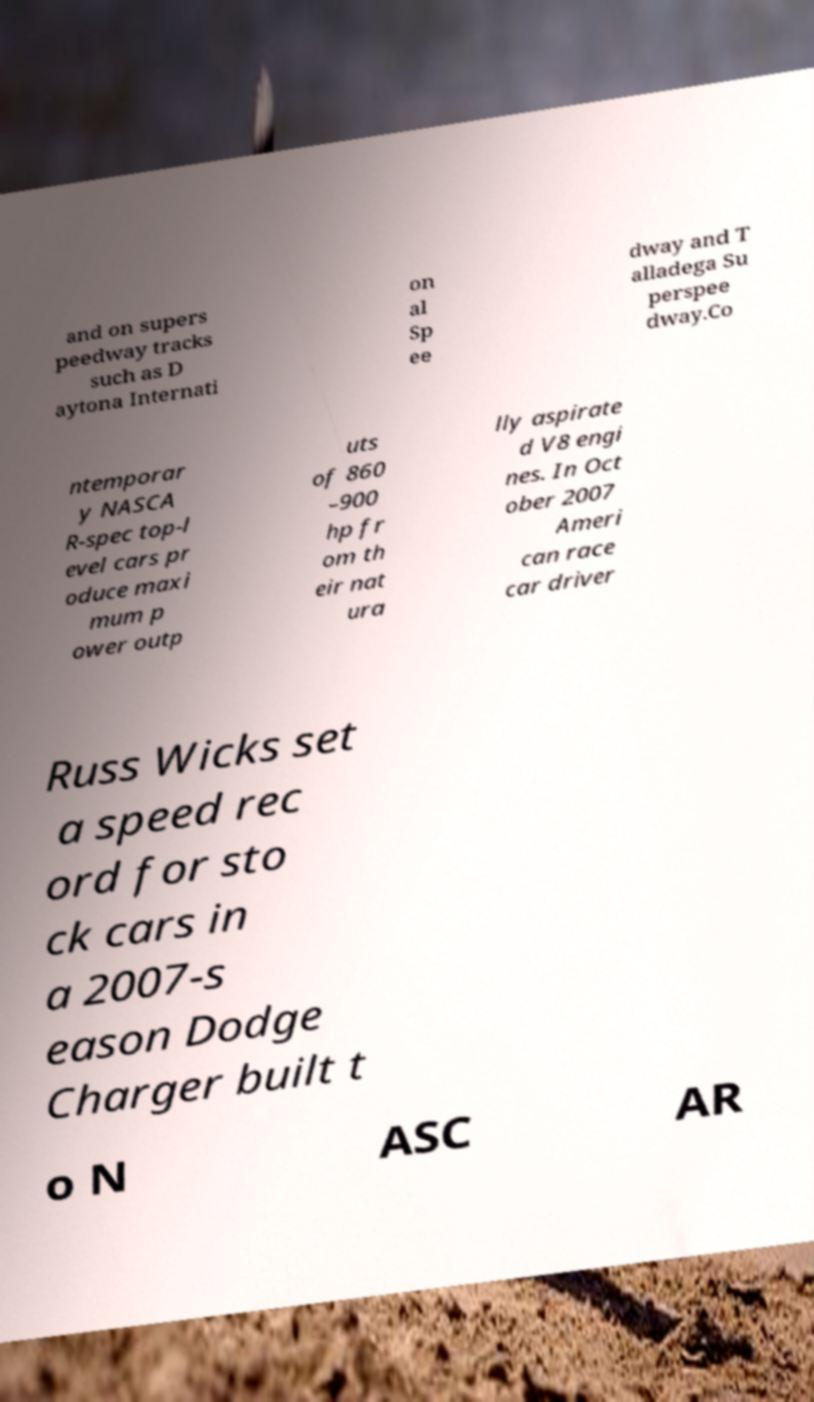Can you read and provide the text displayed in the image?This photo seems to have some interesting text. Can you extract and type it out for me? and on supers peedway tracks such as D aytona Internati on al Sp ee dway and T alladega Su perspee dway.Co ntemporar y NASCA R-spec top-l evel cars pr oduce maxi mum p ower outp uts of 860 –900 hp fr om th eir nat ura lly aspirate d V8 engi nes. In Oct ober 2007 Ameri can race car driver Russ Wicks set a speed rec ord for sto ck cars in a 2007-s eason Dodge Charger built t o N ASC AR 